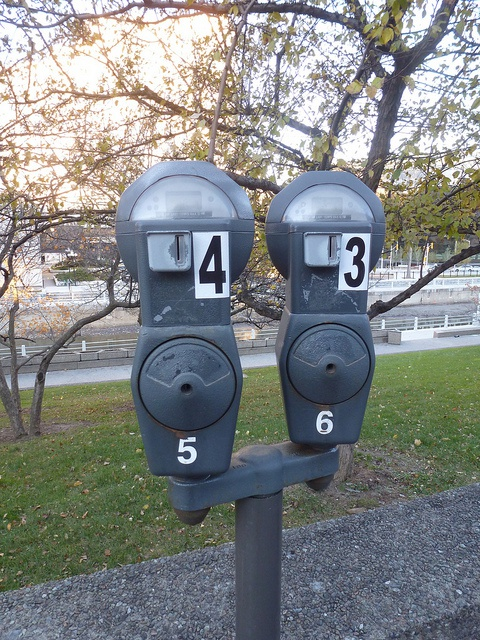Describe the objects in this image and their specific colors. I can see parking meter in white, gray, darkblue, and darkgray tones and parking meter in white, darkblue, gray, and black tones in this image. 